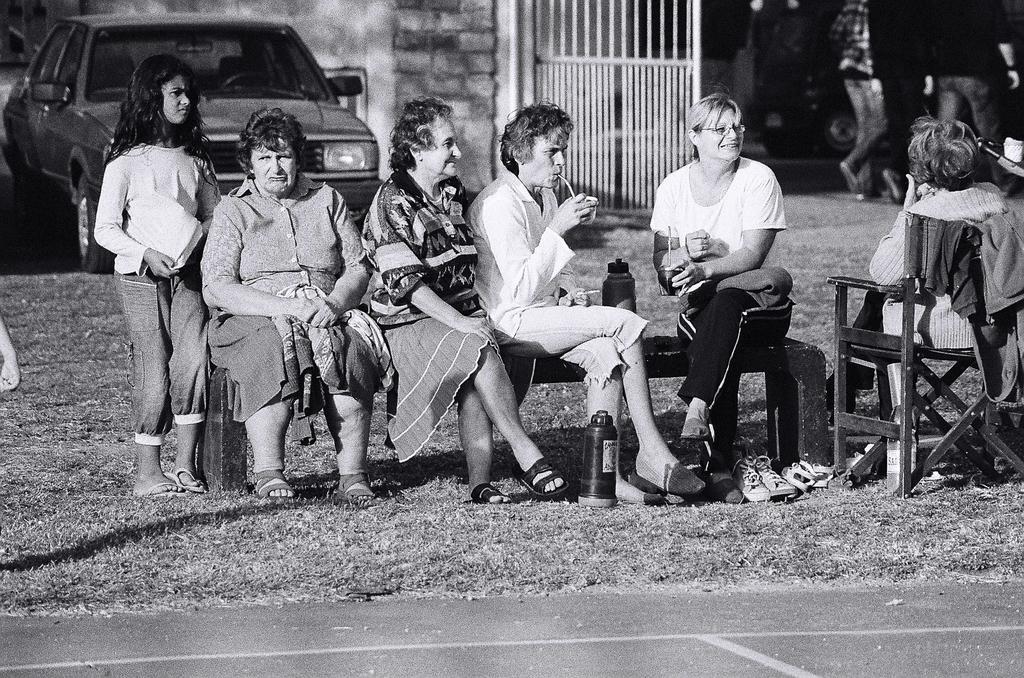Describe this image in one or two sentences. In this picture there are group of people those who are sitting in the center of the image on a bench and there is a chair on the right side of the image, there is a gate in the center of the image, there is a car on the left side of the image and there are other people in the top right side of the image. 